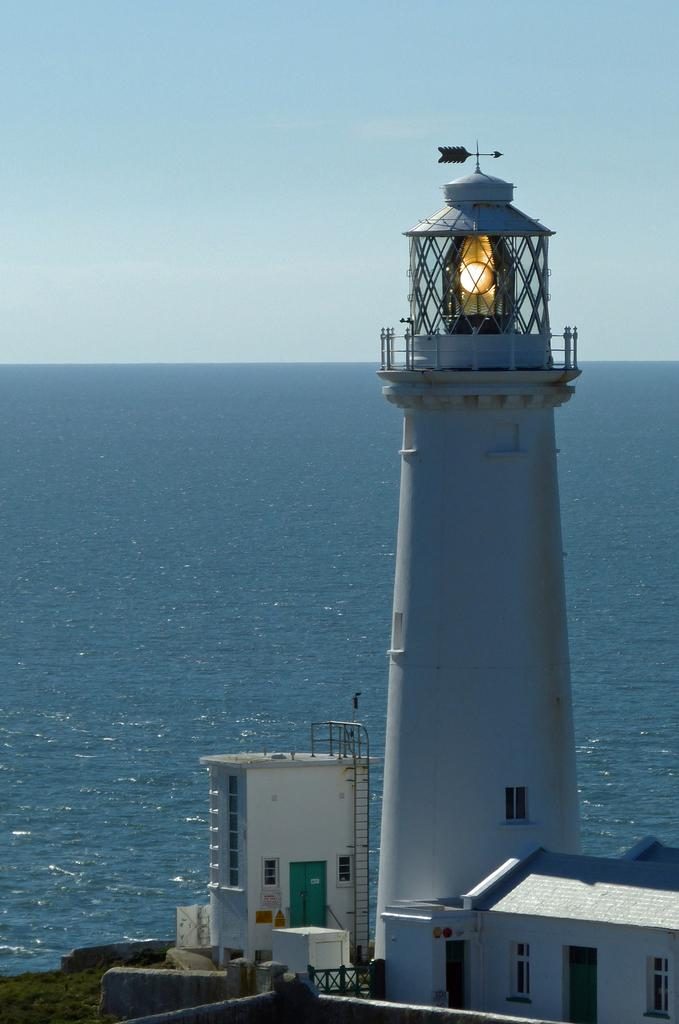What is the main structure in the image? There is a white color lighthouse in the image. What other structures can be seen in the image? There are buildings in the image. What feature is common among some of the structures? There are windows in the image. What is the purpose of the ladder in the image? The ladder is likely used for accessing higher areas of the lighthouse or buildings. What natural element is visible in the image? There is water visible in the image. How would you describe the color of the sky in the image? The sky is in white and blue color. What type of sofa can be seen in the image? There is no sofa present in the image. What color are the trousers worn by the person in the image? There is no person or trousers visible in the image. 